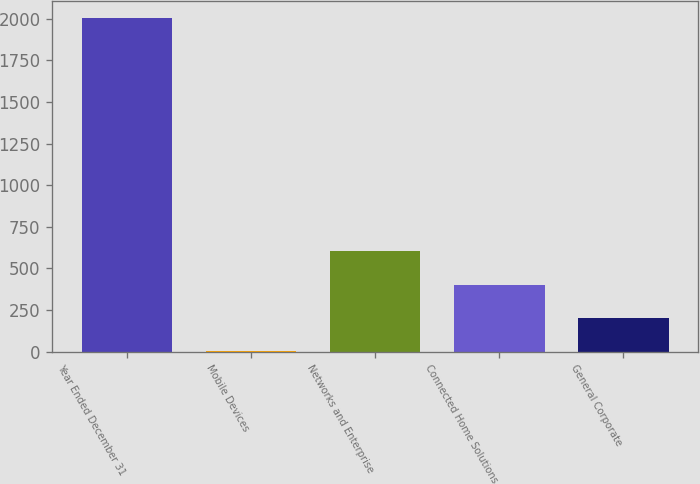Convert chart to OTSL. <chart><loc_0><loc_0><loc_500><loc_500><bar_chart><fcel>Year Ended December 31<fcel>Mobile Devices<fcel>Networks and Enterprise<fcel>Connected Home Solutions<fcel>General Corporate<nl><fcel>2006<fcel>1<fcel>602.5<fcel>402<fcel>201.5<nl></chart> 